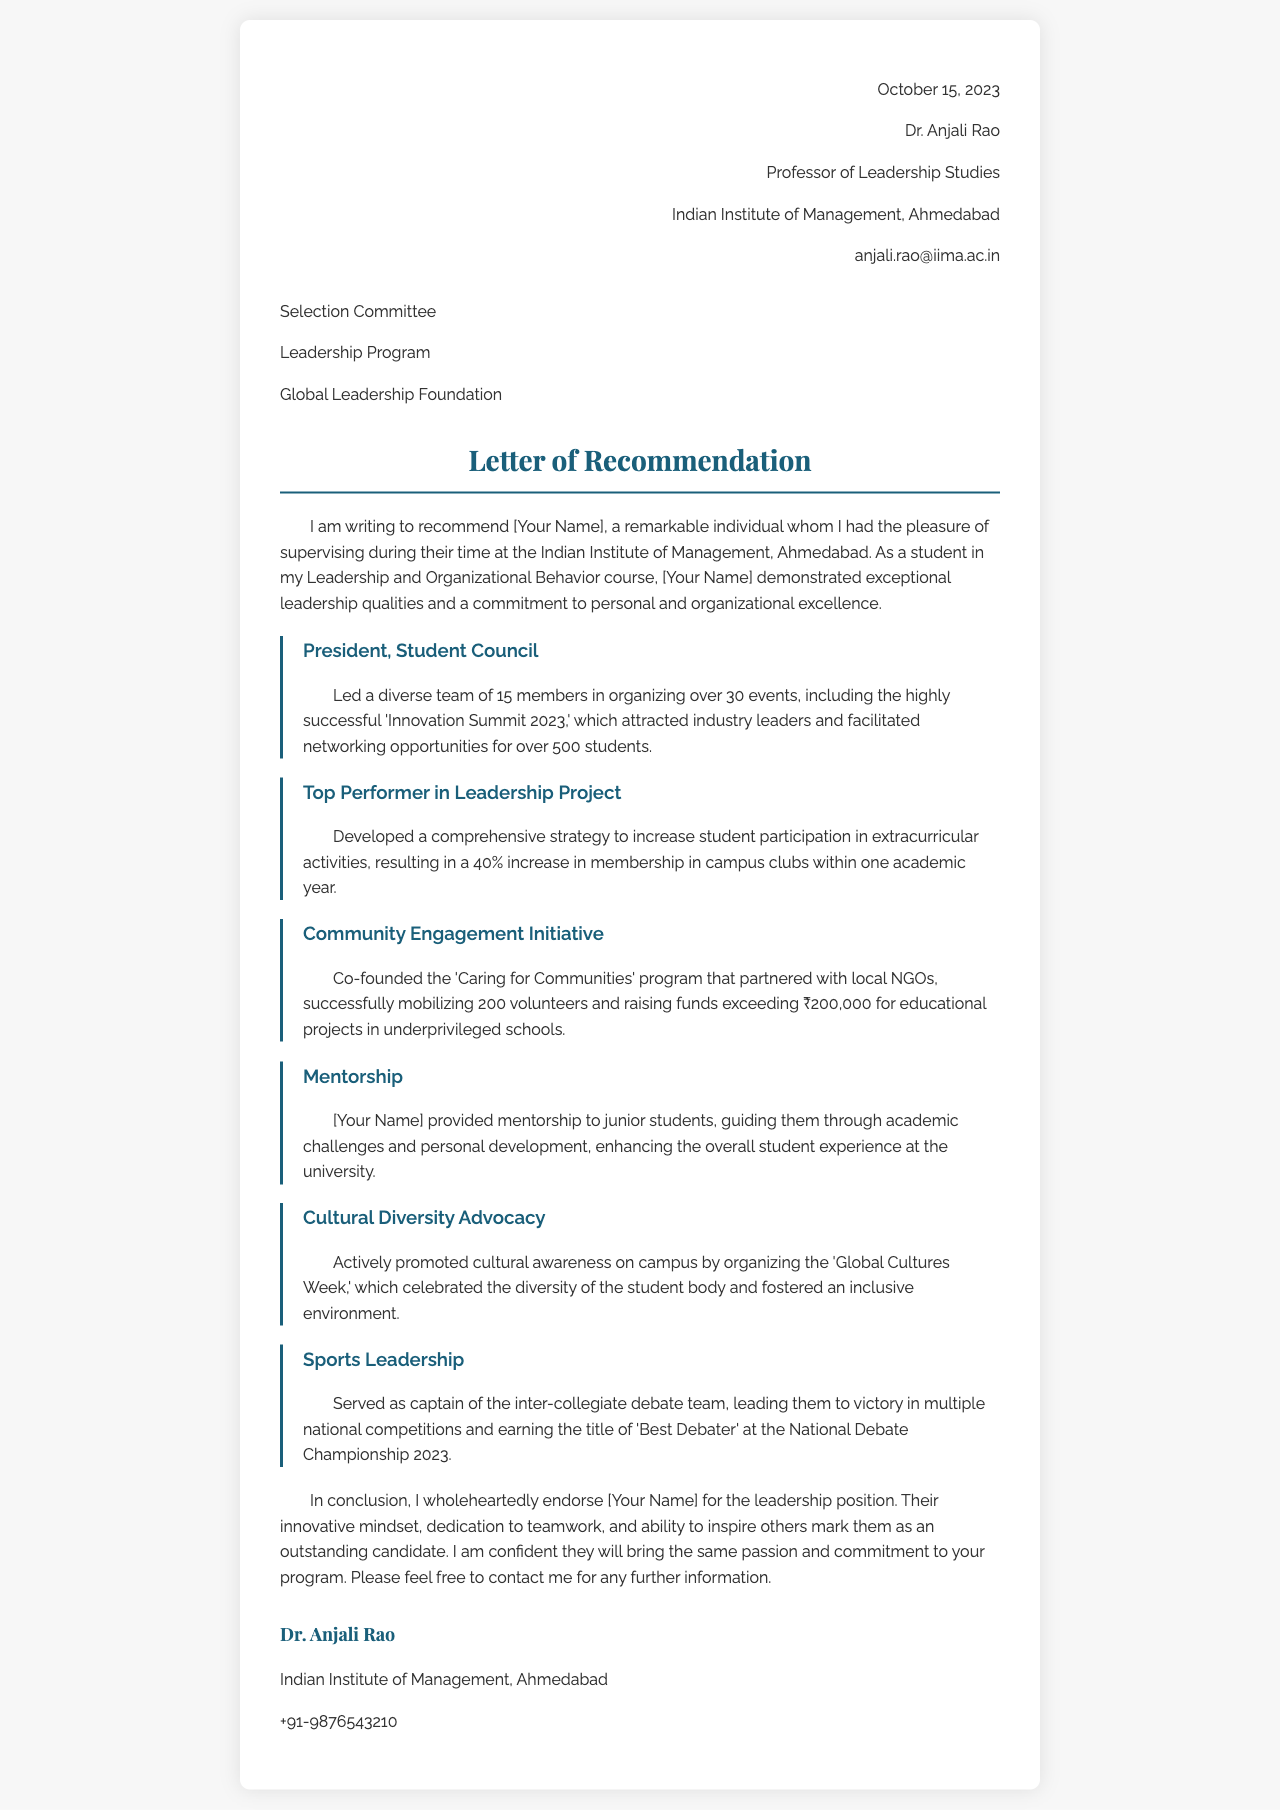what is the date of the letter? The date of the letter is mentioned at the top of the document, which is October 15, 2023.
Answer: October 15, 2023 who is the professor writing the recommendation? The professor writing the recommendation is Dr. Anjali Rao, who is mentioned in the header section.
Answer: Dr. Anjali Rao what position did the individual hold in the Student Council? The document states that the individual held the position of President in the Student Council.
Answer: President how much money was raised for educational projects in underprivileged schools? The document specifies that ₹200,000 was raised for educational projects through the 'Caring for Communities' program.
Answer: ₹200,000 how many members were in the team organized for the Innovation Summit 2023? The letter indicates that a diverse team of 15 members was organized for the Innovation Summit 2023.
Answer: 15 members what title did the individual earn at the National Debate Championship 2023? The letter mentions that the individual earned the title of 'Best Debater' at the National Debate Championship 2023.
Answer: Best Debater which program was co-founded by the individual mentioned in the letter? The letter mentions that the individual co-founded the 'Caring for Communities' program.
Answer: Caring for Communities what was the percentage increase in membership in campus clubs? The document notes a 40% increase in membership in campus clubs after the individual's strategy was implemented.
Answer: 40% what is the main focus of the letter? The main focus of the letter is to recommend the individual for a leadership position, highlighting achievements and contributions during university years.
Answer: Recommend for a leadership position 